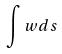Convert formula to latex. <formula><loc_0><loc_0><loc_500><loc_500>\int w d s</formula> 